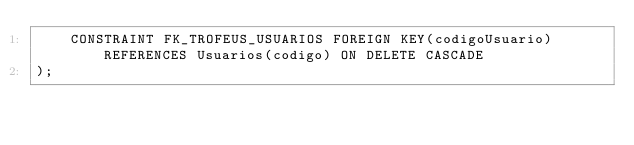<code> <loc_0><loc_0><loc_500><loc_500><_SQL_>    CONSTRAINT FK_TROFEUS_USUARIOS FOREIGN KEY(codigoUsuario) REFERENCES Usuarios(codigo) ON DELETE CASCADE
);</code> 